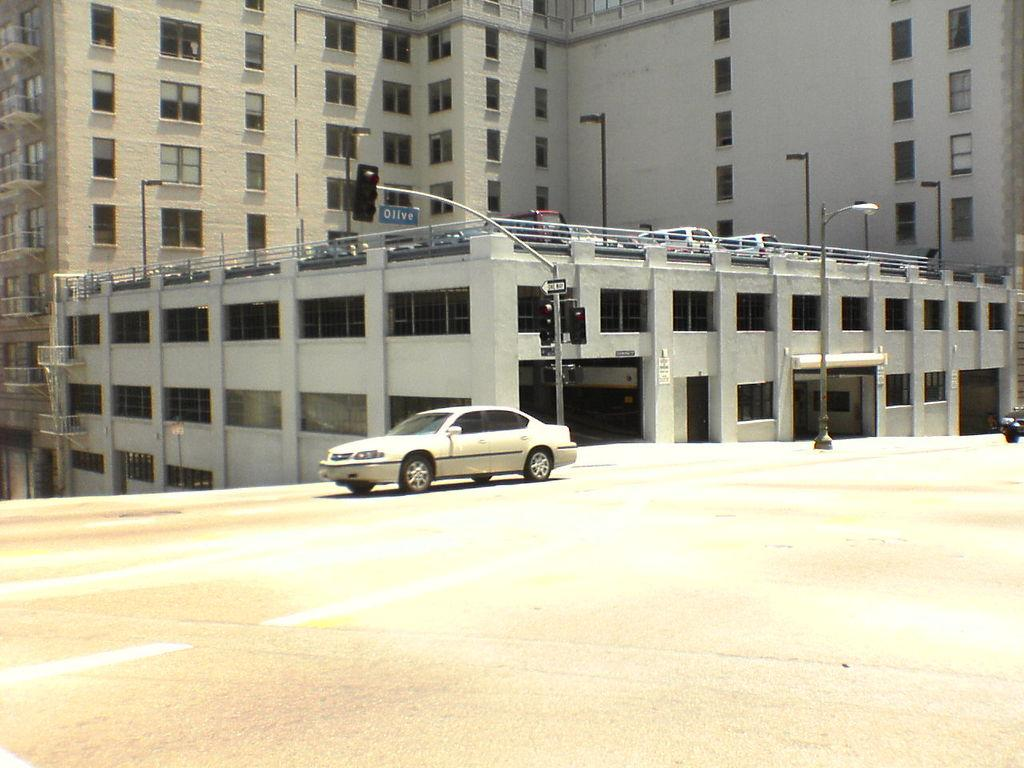What is the main subject in the foreground of the image? There is a car in the foreground of the image. What can be seen in the background of the image? There are buildings in the background of the image. What is unusual about the buildings in the image? There are cars on top of the buildings in the image. What are the poles associated with the cars on top of the buildings used for? The poles associated with the cars on top of the buildings are likely used for support or stability. What is visible at the bottom of the image? There is a road visible at the bottom of the image. What type of wave can be seen crashing into the buildings in the image? There is no wave present in the image; it features buildings with cars on top and a road in the foreground. 